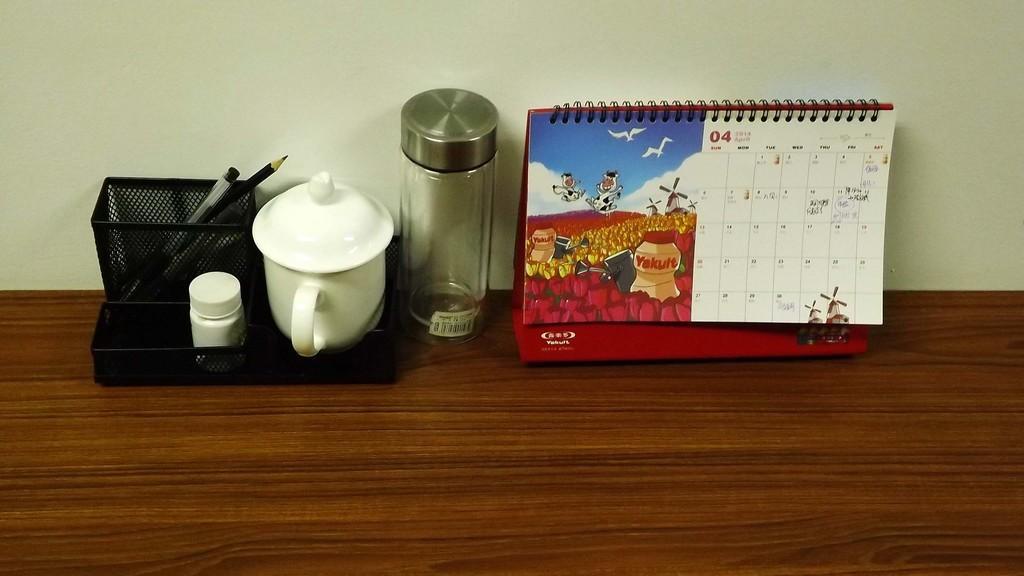Please provide a concise description of this image. On the table there is a pen holder,bottle and a calendar. 